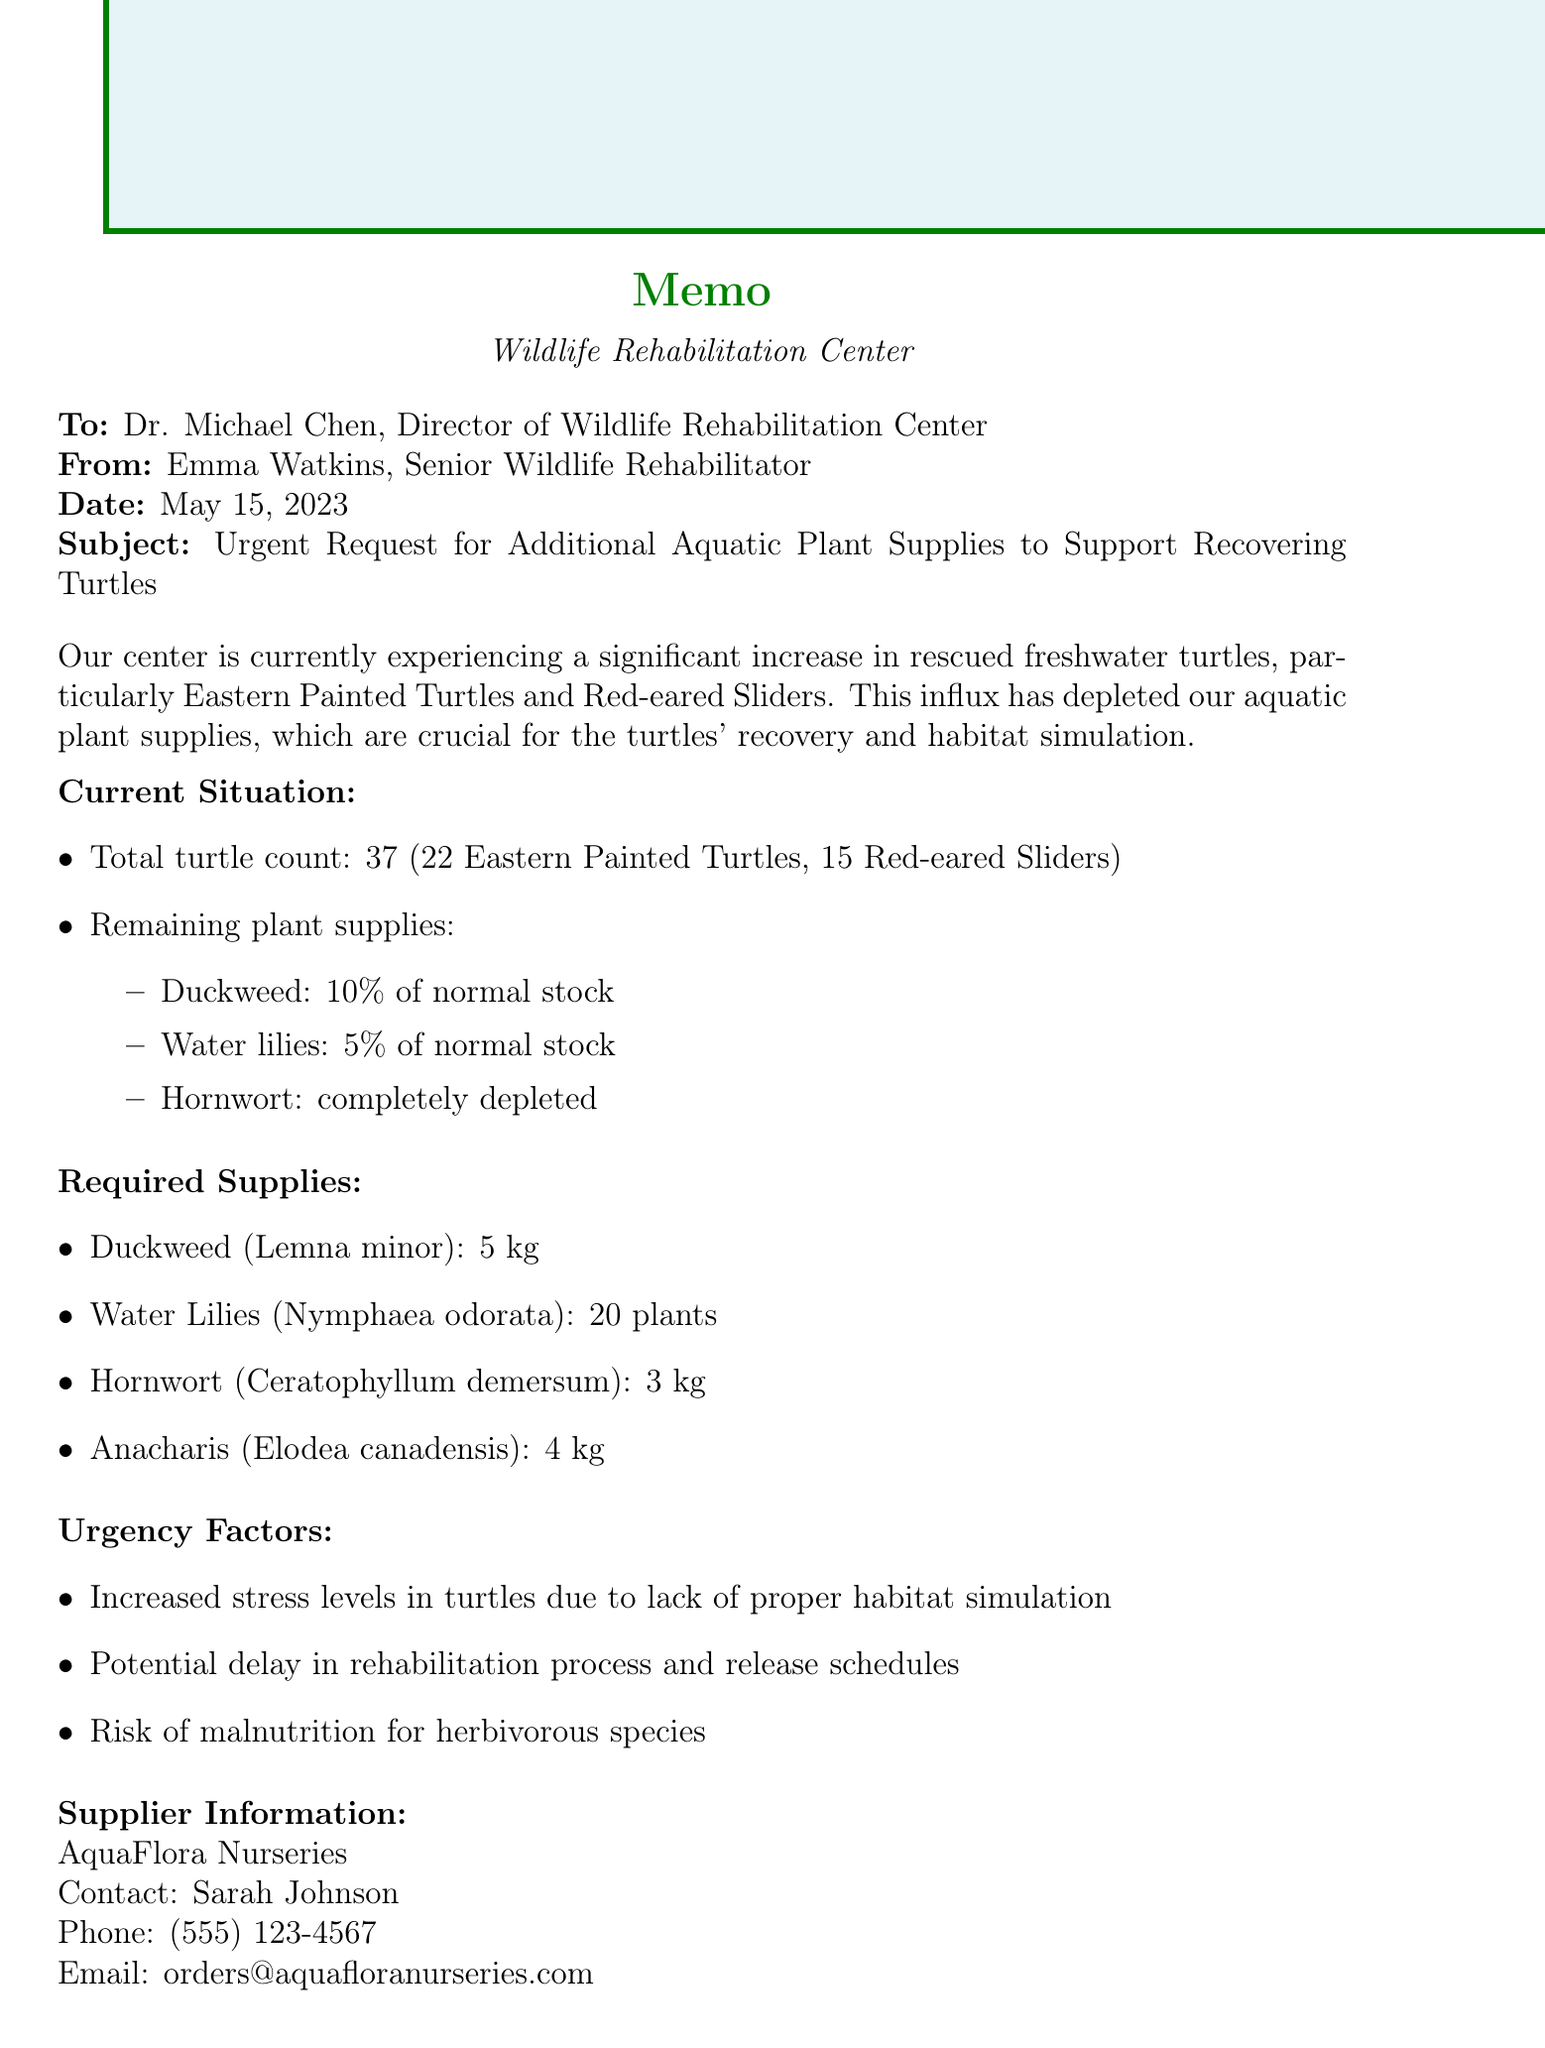What is the title of the memo? The title of the memo is presented clearly at the beginning of the document.
Answer: Urgent Request for Additional Aquatic Plant Supplies to Support Recovering Turtles Who is the sender of the memo? The sender of the memo is indicated directly after the title and recipient information.
Answer: Emma Watkins, Senior Wildlife Rehabilitator What is the date of the memo? The date is explicitly mentioned in the header of the document.
Answer: May 15, 2023 How many Eastern Painted Turtles are currently in recovery? The specific count of Eastern Painted Turtles is provided in the current situation section.
Answer: 22 What is the estimated cost of the required supplies? The estimated cost is listed in the budget impact section of the memo.
Answer: $1,250 What plant is completely depleted? The current supply status of each aquatic plant is provided, indicating which are available and which are not.
Answer: Hornwort What is one of the urgency factors mentioned? The memo lists several urgency factors that highlight the need for immediate action.
Answer: Increased stress levels in turtles due to lack of proper habitat simulation Who should be contacted for ordering the supplies? The supplier information section specifies the contact person for the order.
Answer: Sarah Johnson What is the long-term solution proposed in the memo? The long-term solution is stated towards the end of the memo, offering a sustainable approach.
Answer: Implement an on-site aquatic plant cultivation program 